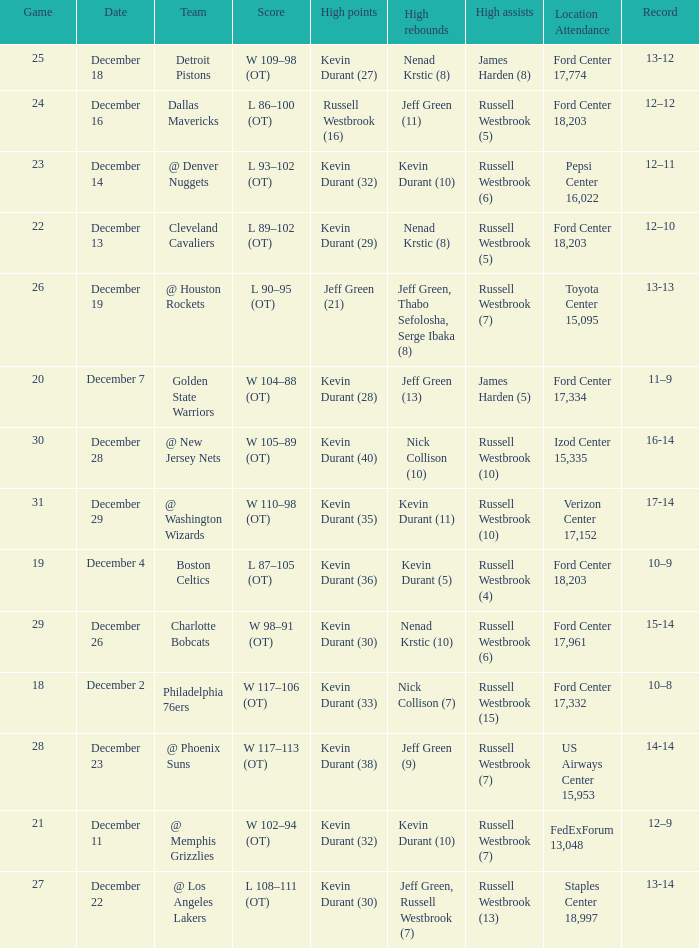What location attendance has russell westbrook (5) as high assists and nenad krstic (8) as high rebounds? Ford Center 18,203. 